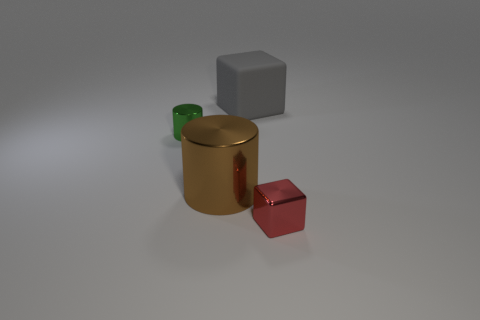There is a cylinder in front of the green cylinder; is its size the same as the thing that is behind the tiny green cylinder?
Provide a short and direct response. Yes. How many other things are there of the same size as the rubber object?
Provide a succinct answer. 1. How many objects are either tiny shiny things behind the small red thing or shiny objects in front of the large brown cylinder?
Provide a succinct answer. 2. Is the tiny cylinder made of the same material as the cube behind the big brown cylinder?
Give a very brief answer. No. What number of other things are there of the same shape as the red metal thing?
Offer a very short reply. 1. What is the material of the cube that is to the left of the object that is on the right side of the big object that is behind the tiny metallic cylinder?
Offer a terse response. Rubber. Are there an equal number of gray objects to the right of the large gray matte cube and tiny green metal balls?
Give a very brief answer. Yes. Do the block that is behind the tiny red thing and the small object that is to the left of the big gray rubber thing have the same material?
Offer a terse response. No. Is there any other thing that has the same material as the small red block?
Your answer should be compact. Yes. There is a brown thing that is on the left side of the big gray cube; is it the same shape as the tiny metal thing on the left side of the large brown shiny cylinder?
Keep it short and to the point. Yes. 